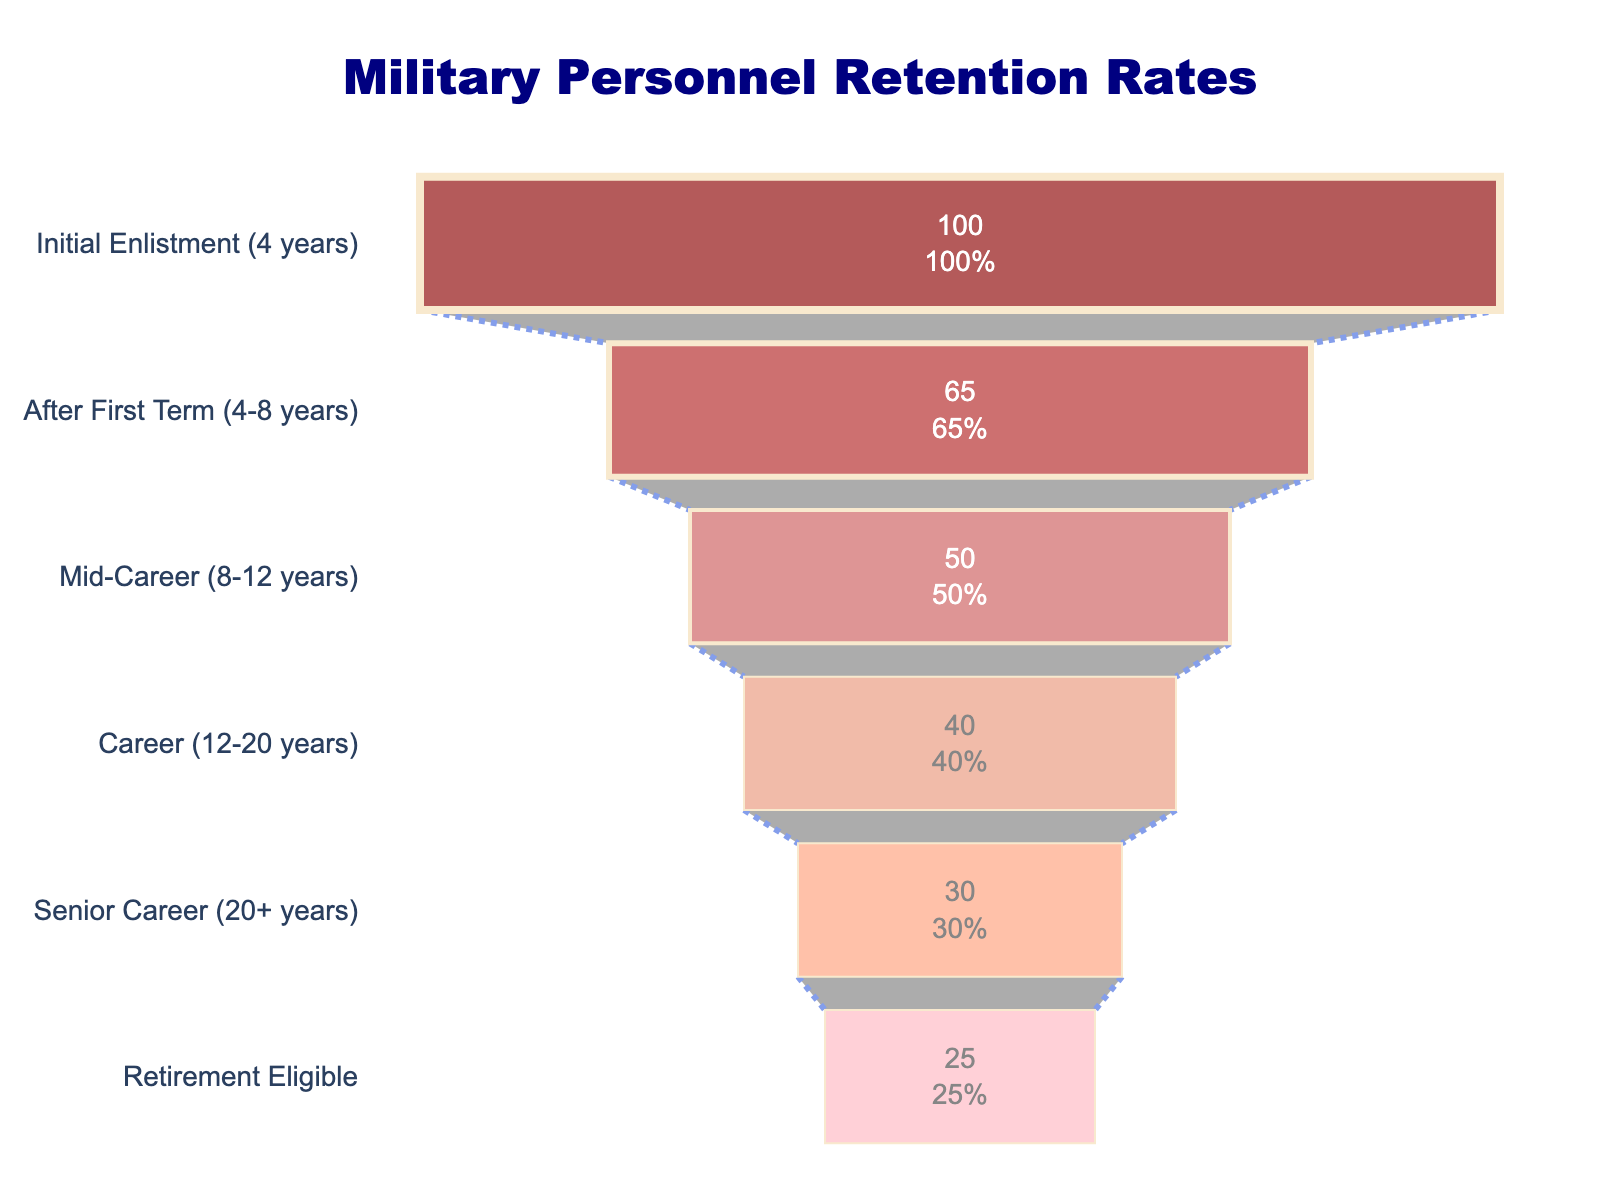what is the retention rate for personnel after the first term (4-8 years)? The retention rate for personnel after the first term is shown directly in the funnel chart, labeled as "After First Term (4-8 years)".
Answer: 65% how many different service length categories are displayed in the chart? The funnel chart has labeled segments representing different service lengths, and we can count these labels.
Answer: 6 Which service length category has the lowest retention rate? By examining the retention rates in descending order from top to bottom in the chart, the lowest rate appears in the "Retirement Eligible" category.
Answer: Retirement Eligible what is the difference in retention rates between mid-career (8-12 years) and senior career (20+ years)? The retention rate for mid-career is 50%, and for senior career it is 30%. Subtracting the two gives 50% - 30%.
Answer: 20% Calculate the average retention rate across all service lengths. Sum the retention rates: 100% + 65% + 50% + 40% + 30% + 25% = 310%, then divide by the number of categories, which is 6. So, 310% / 6.
Answer: 51.67% which transition shows the greatest drop in retention rate? The funnel chart funnels down from top to bottom. The largest difference appears between "Initial Enlistment (4 years)" and "After First Term (4-8 years)", which is 100% - 65%.
Answer: Initial Enlistment to After First Term What percentage of initial personnel are retained by the retirement eligible stage? The retention rate for "Retirement Eligible" is directly given, and it represents the percentage of initial personnel still retained at this stage.
Answer: 25% how much lower is the retention rate at the Retirement Eligible stage compared to the Career stage (12-20 years)? Subtract the retention rate of "Retirement Eligible" (25%) from the retention rate of "Career (12-20 years)" (40%).
Answer: 15% what general trend can be observed in the retention rates over the different service lengths? Looking at the funnel chart, the retention rates steadily decrease from the "Initial Enlistment" stage down to the "Retirement Eligible" stage.
Answer: Decreasing trend 